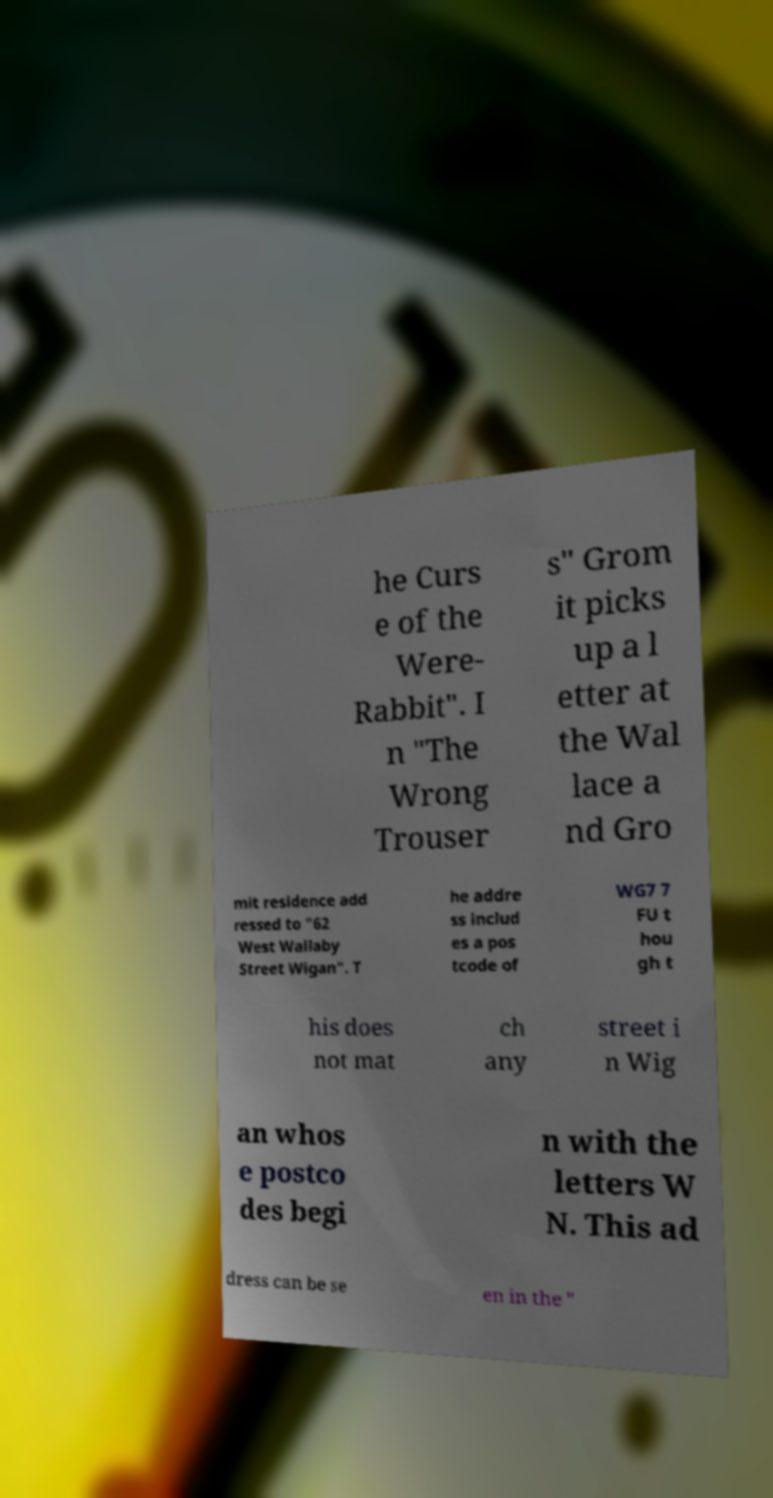Can you read and provide the text displayed in the image?This photo seems to have some interesting text. Can you extract and type it out for me? he Curs e of the Were- Rabbit". I n "The Wrong Trouser s" Grom it picks up a l etter at the Wal lace a nd Gro mit residence add ressed to "62 West Wallaby Street Wigan". T he addre ss includ es a pos tcode of WG7 7 FU t hou gh t his does not mat ch any street i n Wig an whos e postco des begi n with the letters W N. This ad dress can be se en in the " 